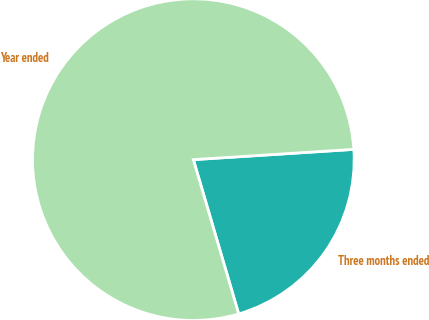<chart> <loc_0><loc_0><loc_500><loc_500><pie_chart><fcel>Three months ended<fcel>Year ended<nl><fcel>21.47%<fcel>78.53%<nl></chart> 